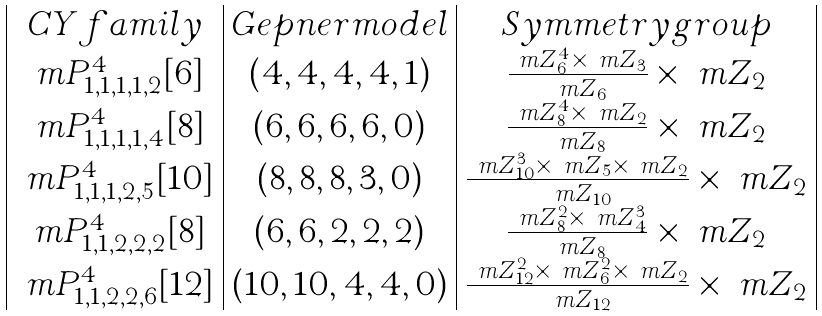Convert formula to latex. <formula><loc_0><loc_0><loc_500><loc_500>\begin{array} { | c | c | c | } C Y f a m i l y & G e p n e r m o d e l & S y m m e t r y g r o u p \\ \ m P _ { 1 , 1 , 1 , 1 , 2 } ^ { 4 } [ 6 ] & ( 4 , 4 , 4 , 4 , 1 ) & \frac { \ m Z _ { 6 } ^ { 4 } \times \ m Z _ { 3 } } { \ m Z _ { 6 } } \times \ m Z _ { 2 } \\ \ m P _ { 1 , 1 , 1 , 1 , 4 } ^ { 4 } [ 8 ] & ( 6 , 6 , 6 , 6 , 0 ) & \frac { \ m Z _ { 8 } ^ { 4 } \times \ m Z _ { 2 } } { \ m Z _ { 8 } } \times \ m Z _ { 2 } \\ \ m P _ { 1 , 1 , 1 , 2 , 5 } ^ { 4 } [ 1 0 ] & ( 8 , 8 , 8 , 3 , 0 ) & \frac { \ m Z _ { 1 0 } ^ { 3 } \times \ m Z _ { 5 } \times \ m Z _ { 2 } } { \ m Z _ { 1 0 } } \times \ m Z _ { 2 } \\ \ m P _ { 1 , 1 , 2 , 2 , 2 } ^ { 4 } [ 8 ] & ( 6 , 6 , 2 , 2 , 2 ) & \frac { \ m Z _ { 8 } ^ { 2 } \times \ m Z _ { 4 } ^ { 3 } } { \ m Z _ { 8 } } \times \ m Z _ { 2 } \\ \ m P _ { 1 , 1 , 2 , 2 , 6 } ^ { 4 } [ 1 2 ] & ( 1 0 , 1 0 , 4 , 4 , 0 ) & \frac { \ m Z _ { 1 2 } ^ { 2 } \times \ m Z _ { 6 } ^ { 2 } \times \ m Z _ { 2 } } { \ m Z _ { 1 2 } } \times \ m Z _ { 2 } \\ \end{array}</formula> 